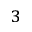<formula> <loc_0><loc_0><loc_500><loc_500>^ { 3 }</formula> 